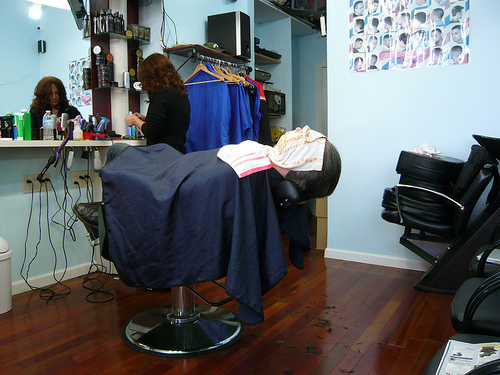<image>
Can you confirm if the woman is on the chair? No. The woman is not positioned on the chair. They may be near each other, but the woman is not supported by or resting on top of the chair. 